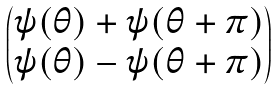Convert formula to latex. <formula><loc_0><loc_0><loc_500><loc_500>\begin{pmatrix} \psi ( \theta ) + \psi ( \theta + \pi ) \\ \psi ( \theta ) - \psi ( \theta + \pi ) \end{pmatrix}</formula> 